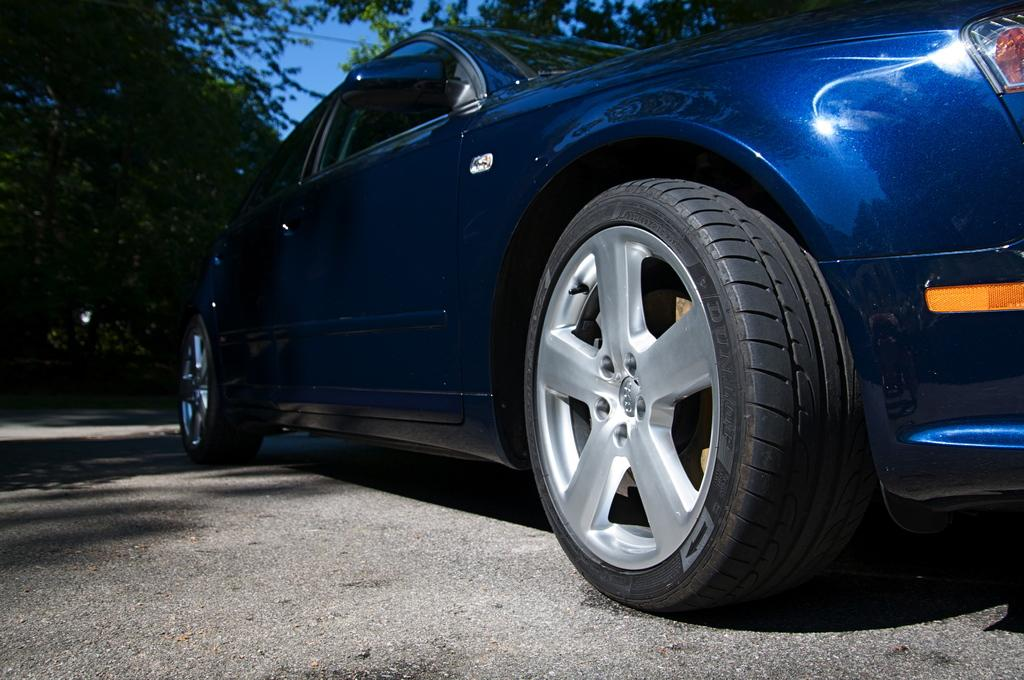What color is the car in the image? The car in the image is blue. Where is the car located in the image? The car is parked on the road. From what angle is the car being viewed in the image? The view of the car is from a lower angle. What can be seen in the background of the image? There are trees and the sky visible in the background of the image. Are there any deer visible in the image? No, there are no deer present in the image. 